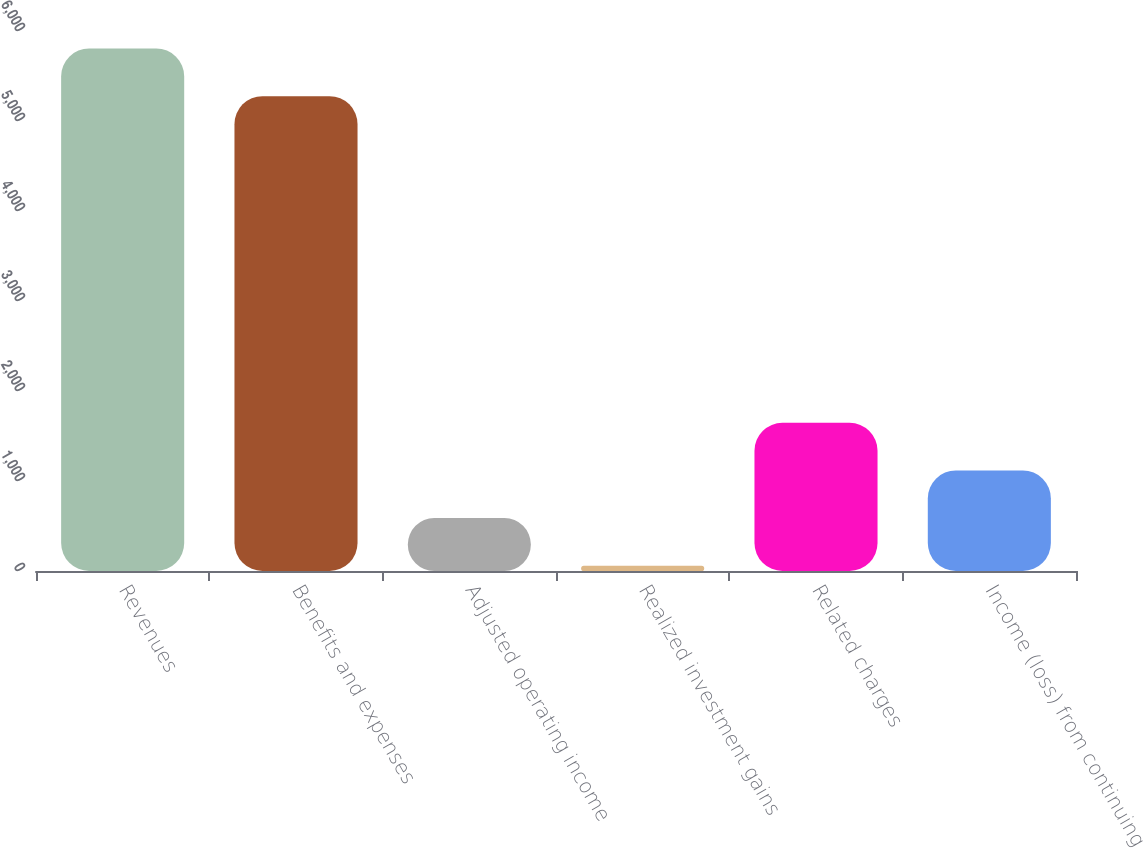Convert chart to OTSL. <chart><loc_0><loc_0><loc_500><loc_500><bar_chart><fcel>Revenues<fcel>Benefits and expenses<fcel>Adjusted operating income<fcel>Realized investment gains<fcel>Related charges<fcel>Income (loss) from continuing<nl><fcel>5805.7<fcel>5276<fcel>587.7<fcel>58<fcel>1647.1<fcel>1117.4<nl></chart> 